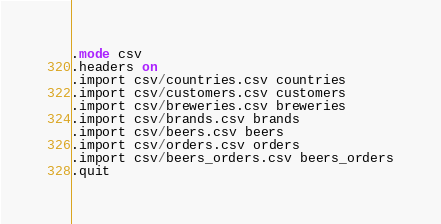Convert code to text. <code><loc_0><loc_0><loc_500><loc_500><_SQL_>.mode csv
.headers on
.import csv/countries.csv countries
.import csv/customers.csv customers
.import csv/breweries.csv breweries
.import csv/brands.csv brands
.import csv/beers.csv beers
.import csv/orders.csv orders
.import csv/beers_orders.csv beers_orders
.quit
</code> 